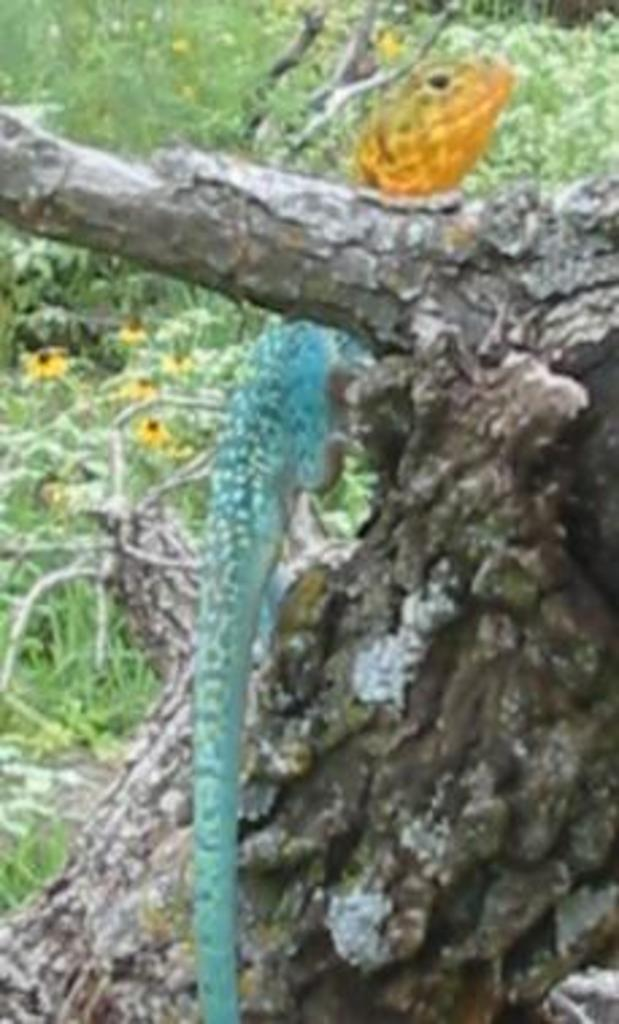What type of animal is in the image? There is a reptile in the image. What is the reptile resting on? The reptile is on a wooden object. What is the ground like in the image? Grass is visible on the ground in the image. What can be seen in the background of the image? There are flowers and plants visible in the background of the image. What type of business is being conducted in the image? There is no indication of any business activity in the image; it features a reptile on a wooden object with grass and plants in the background. 